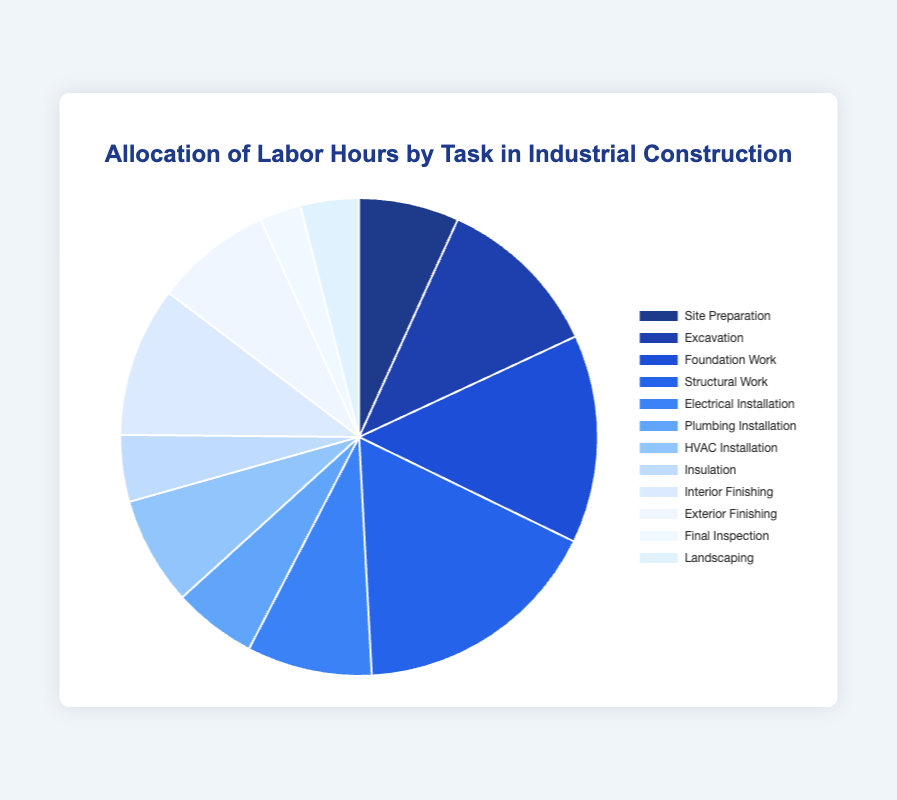What task requires the most labor hours? To determine the task requiring the most labor hours, we look at the segment with the largest slice in the pie chart and its corresponding label. "Structural Work" has the largest slice, indicating it requires the most labor hours.
Answer: Structural Work Which tasks require less than 100 labor hours each? To identify tasks requiring fewer than 100 labor hours, we examine the smaller segments of the pie chart and their labels. The tasks "Insulation" and "Final Inspection" fit this criterion.
Answer: Insulation, Final Inspection What is the proportional labor hour distribution between Foundation Work and Excavation? To find the proportional distribution, we look at the slices corresponding to "Foundation Work" and "Excavation" in the pie chart. "Foundation Work" is larger than "Excavation". Foundation Work requires 250 hours, while Excavation requires 200 hours. Therefore, the ratio is 250 to 200 or 1.25 to 1.
Answer: 1.25 to 1 Are there more labor hours allocated to Site Preparation or Electrical Installation? Check the size of the slices for "Site Preparation" and "Electrical Installation" in the pie chart. "Electrical Installation" has a slightly larger slice than "Site Preparation", indicating more labor hours.
Answer: Electrical Installation How many total labor hours are allocated to finishing tasks (Interior and Exterior Finishing combined)? Adding the labor hours for "Interior Finishing" (180) and "Exterior Finishing" (140) gives us the total labor hours for finishing tasks. 180 + 140 = 320.
Answer: 320 What percent of the total labor hours is dedicated to HVAC Installation? The percentage is calculated by dividing the labor hours for "HVAC Installation" (130) by the total labor hours and then multiplying by 100. Total labor hours are 1770. (130/1770) * 100 ≈ 7.34%.
Answer: 7.34% If labor hours for Final Inspection increased by 100%, how would its new labor allocation compare with Site Preparation? Doubling the labor hours for "Final Inspection" makes it 50 * 2 = 100. Compare this with "Site Preparation" which has 120 hours. "Site Preparation" would still have more hours than the increased value for "Final Inspection".
Answer: Site Preparation What is the combined percentage of labor hours for Plumbing Installation and Landscaping? Calculate the combined labor hours for Plumbing Installation (100) and Landscaping (70) which equals 170. Then divide by the total labor hours (1770) and multiply by 100. (170/1770) * 100 ≈ 9.60%.
Answer: 9.60% Is the labor hour allocation for Insulation or HVAC Installation smaller, and by how much? Compare the labor hours for "Insulation" and "HVAC Installation". "Insulation" has 80 hours while "HVAC Installation" has 130 hours. The difference is 130 - 80 = 50 hours.
Answer: Insulation by 50 hours Which task has the smallest labor hour allocation and what is its share as a percentage of the total? Identify the smallest slice in the pie chart, which corresponds to "Final Inspection" with 50 hours. Calculate the percentage: (50/1770) * 100 ≈ 2.82%.
Answer: Final Inspection, 2.82% 